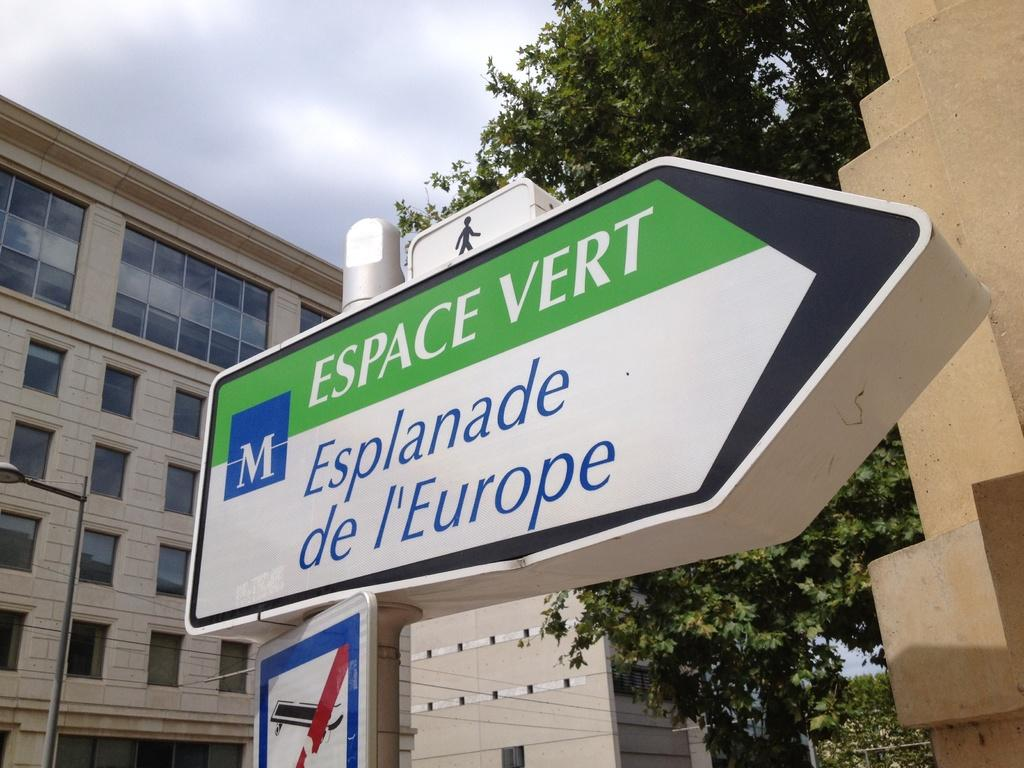What type of structures can be seen in the image? There are buildings in the image. What other natural elements are present in the image? There are trees in the image. What is located at the front of the image? There is a sign board at the front of the image. What can be seen at the left side of the image? There is a street light at the left side of the image. What is visible in the background of the image? The sky is visible in the background of the image. What belief is depicted in the story being told at the seashore in the image? There is no story or seashore present in the image; it features buildings, trees, a sign board, a street light, and the sky. 